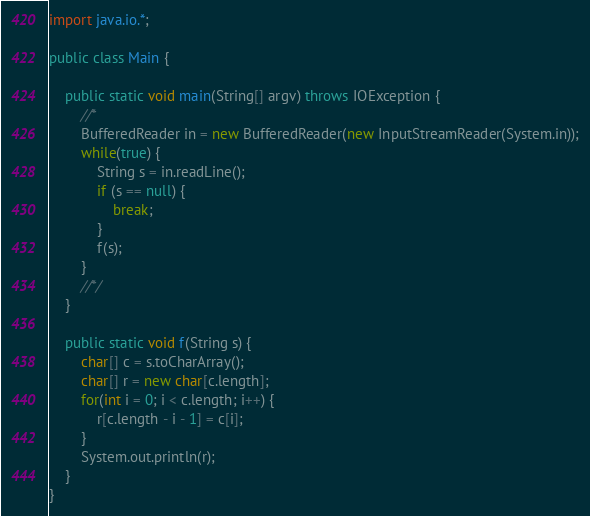<code> <loc_0><loc_0><loc_500><loc_500><_Java_>
import java.io.*;

public class Main {

    public static void main(String[] argv) throws IOException {
        //*
        BufferedReader in = new BufferedReader(new InputStreamReader(System.in));
        while(true) {
            String s = in.readLine();
            if (s == null) {
                break;
            }
            f(s);
        }
        //*/
    }

    public static void f(String s) {
        char[] c = s.toCharArray();
        char[] r = new char[c.length];
        for(int i = 0; i < c.length; i++) {
            r[c.length - i - 1] = c[i];
        }
        System.out.println(r);
    }
}</code> 